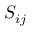<formula> <loc_0><loc_0><loc_500><loc_500>S _ { i j }</formula> 